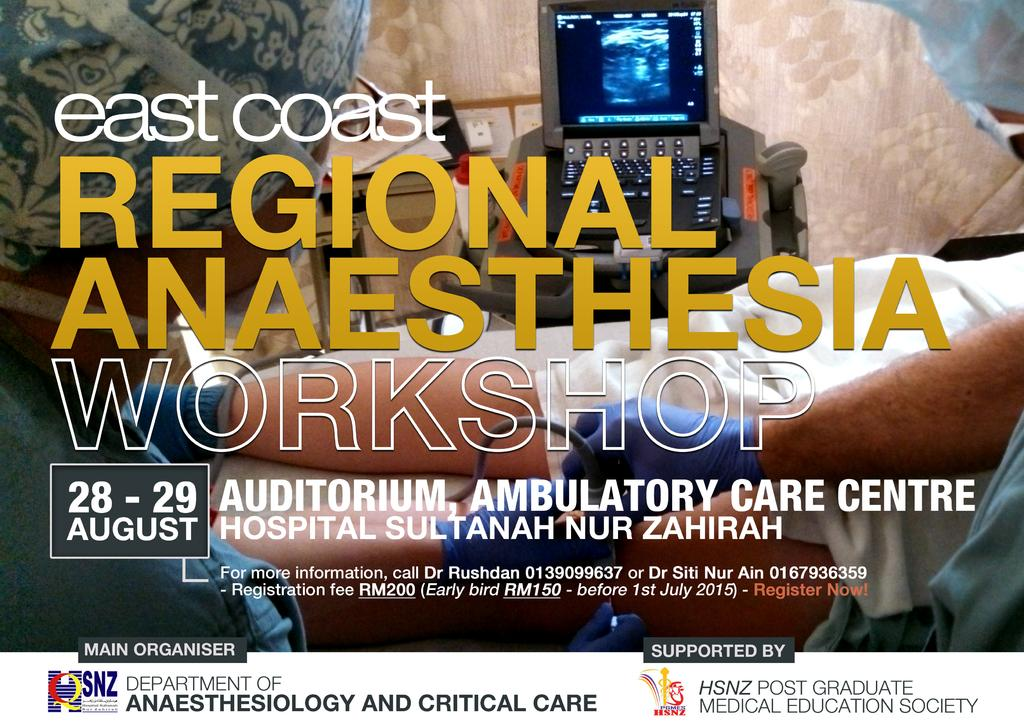<image>
Provide a brief description of the given image. An advertisement for a regional anaesthesia office showing a doctor putting a syringe in a patient. 